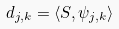<formula> <loc_0><loc_0><loc_500><loc_500>d _ { j , k } = \langle S , \psi _ { j , k } \rangle</formula> 